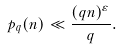<formula> <loc_0><loc_0><loc_500><loc_500>p _ { q } ( n ) \ll \frac { ( q n ) ^ { \varepsilon } } { q } .</formula> 